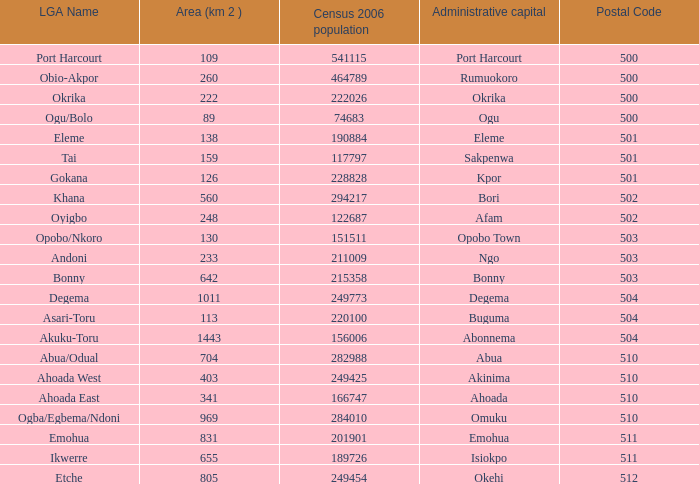What is the district when the iga name is ahoada east? 341.0. 